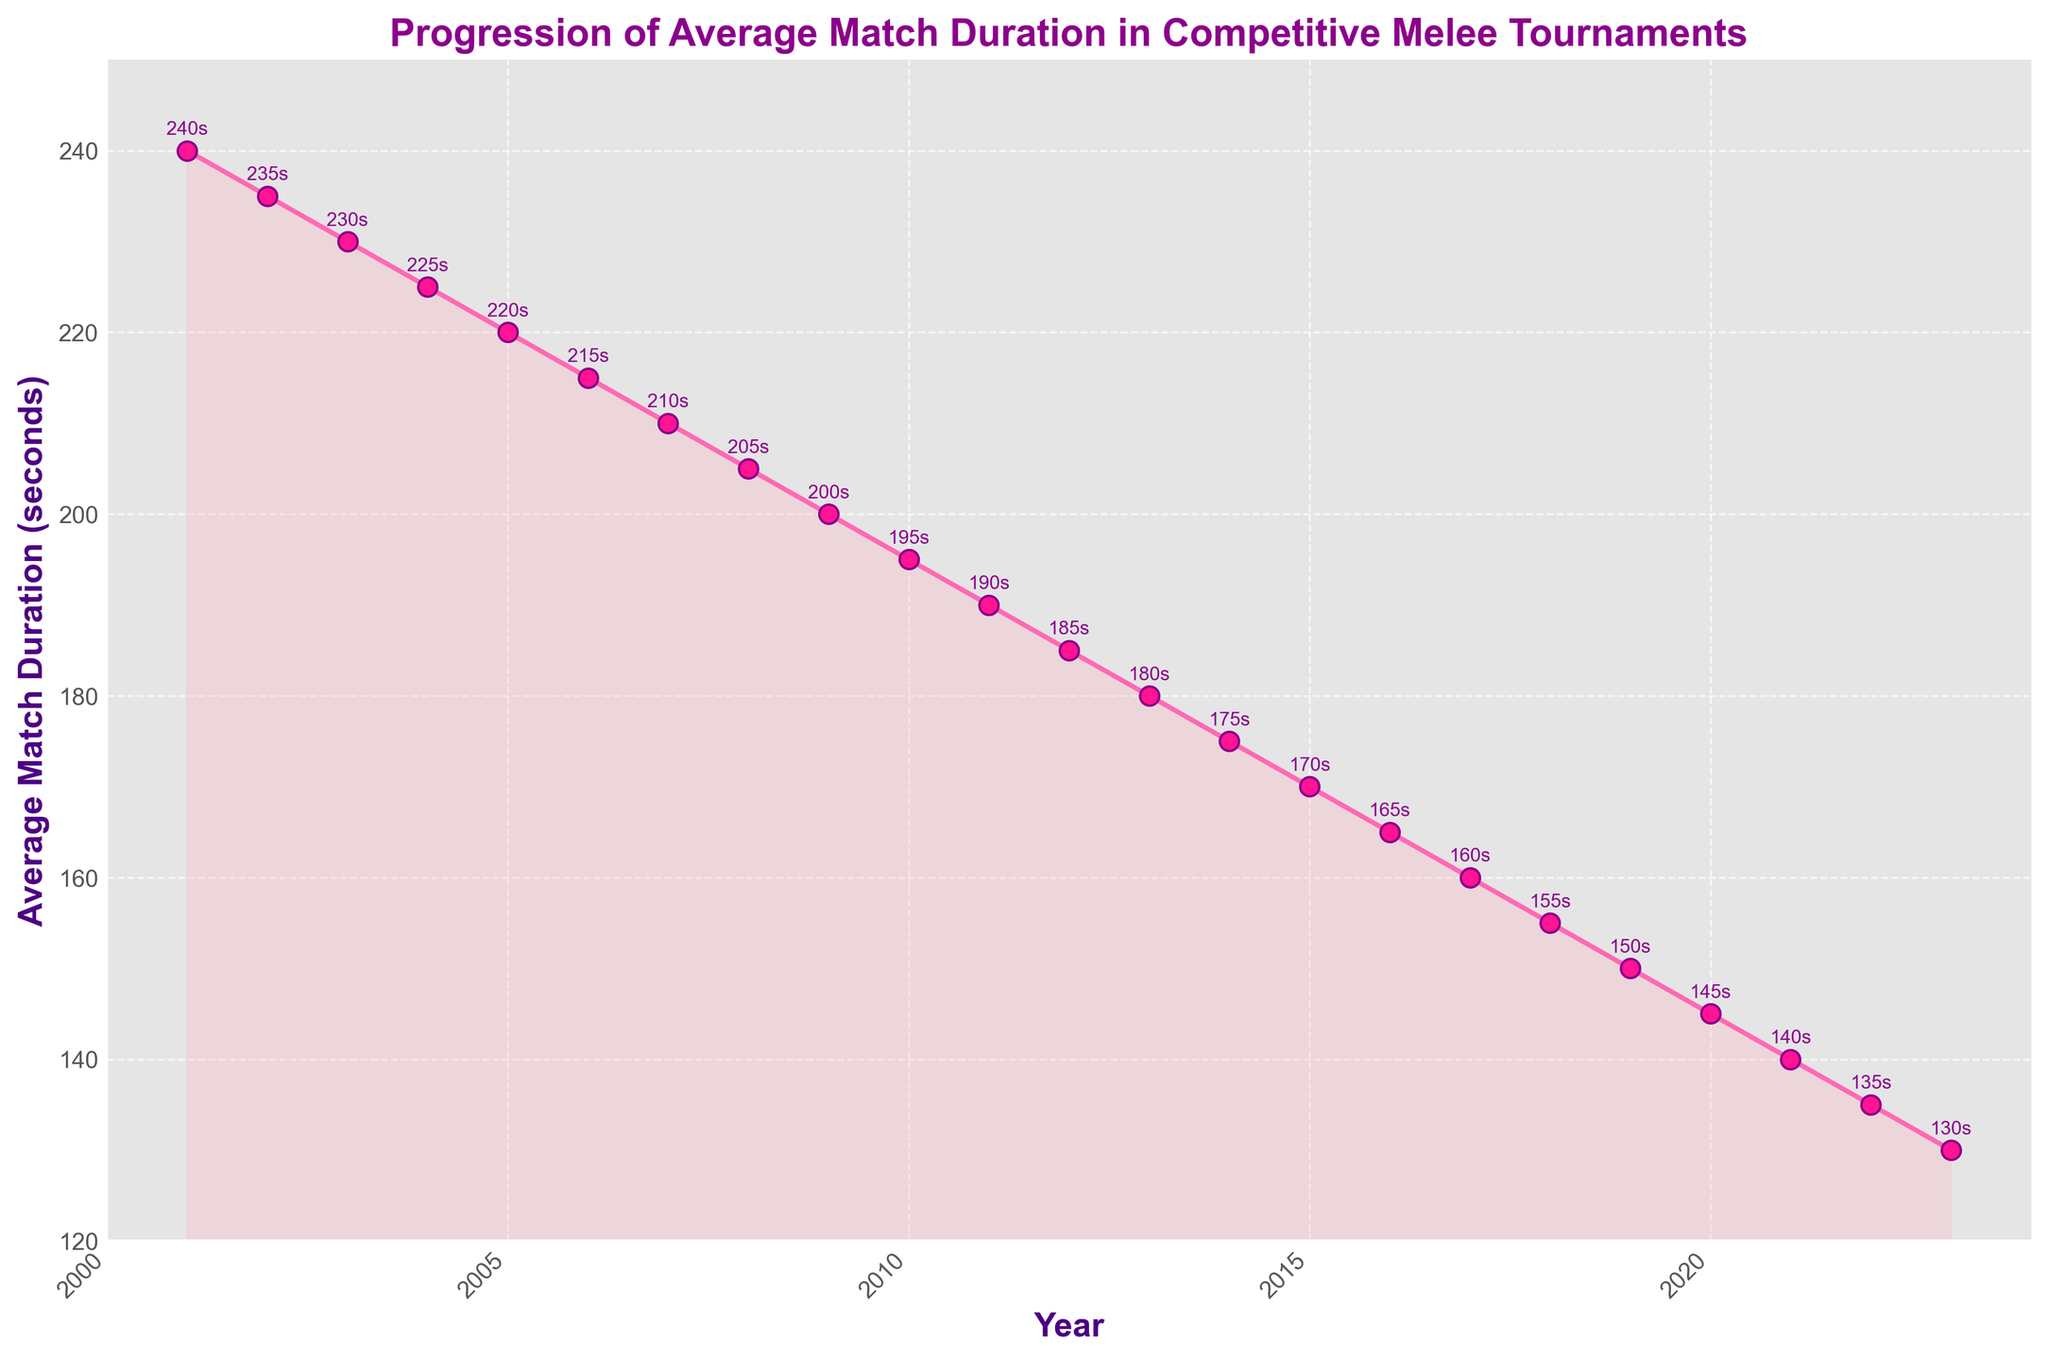What was the average match duration in 2015 and how does it compare to the duration in 2023? The average match duration in 2015 was 170 seconds, and in 2023, it was 130 seconds. The difference is 170 - 130 = 40 seconds.
Answer: The average match duration decreased by 40 seconds What is the trend in average match duration from 2001 to 2023? From 2001 to 2023, the average match duration consistently decreased each year, starting from 240 seconds in 2001 and going down to 130 seconds in 2023. The graph shows a continuous downward trend.
Answer: It decreases consistently Which year had the highest average match duration and what was it? The highest average match duration was in 2001 with a duration of 240 seconds. This can be seen at the beginning of the line chart where the duration was highest.
Answer: 2001, 240 seconds Between which consecutive years was the greatest single-year drop in average match duration observed? By examining the plot, the greatest single-year drop in average match duration occurred between 2020 (145 seconds) and 2021 (140 seconds), a decrease of 5 seconds.
Answer: Between 2020 and 2021 How much did the average match duration decrease on average per year from 2001 to 2023? The total decrease in average match duration over the years from 2001 to 2023 is 240 - 130 = 110 seconds. There are 22 years between 2001 and 2023. Therefore, the average decrease per year is 110/22 = 5 seconds per year.
Answer: 5 seconds per year What can be inferred about the competitiveness and speed of Melee matches over the years from this plot? As the average match duration has consistently decreased from 240 seconds in 2001 to 130 seconds in 2023, it can be inferred that the matches have become faster and possibly more competitive over the years, indicating improvements in player skills, strategies, and efficiency.
Answer: Matches have become faster and possibly more competitive How does the average match duration in 2005 compare to that in 2015? In 2005, the average match duration was 220 seconds, whereas in 2015, it was 170 seconds. Therefore, the duration decreased by 220 - 170 = 50 seconds over this 10-year period.
Answer: It decreased by 50 seconds If the trend continues, what could be a reasonable prediction for the average match duration in 2024? Given the consistent decrease of approximately 5 seconds per year, extrapolating this trend indicates that the average match duration in 2024 could be around 130 (2023 duration) - 5 = 125 seconds.
Answer: Around 125 seconds Which visual aspects of the plot highlight the overall trend in average match duration? The use of a line plot with downward slopes, the consistent spacing between markers showing a smooth decrease, and the shaded area under the line (with lighter color) all highlight the overall trend of decreasing average match duration over time.
Answer: Downward slopes, consistent spacing, and shaded area When was the average match duration first recorded to be below 200 seconds? Observing the plot, the average match duration first fell below 200 seconds in 2009, where it reached 200 seconds. The following year, 2010, shows it clearly below 200 seconds at 195 seconds.
Answer: 2010 